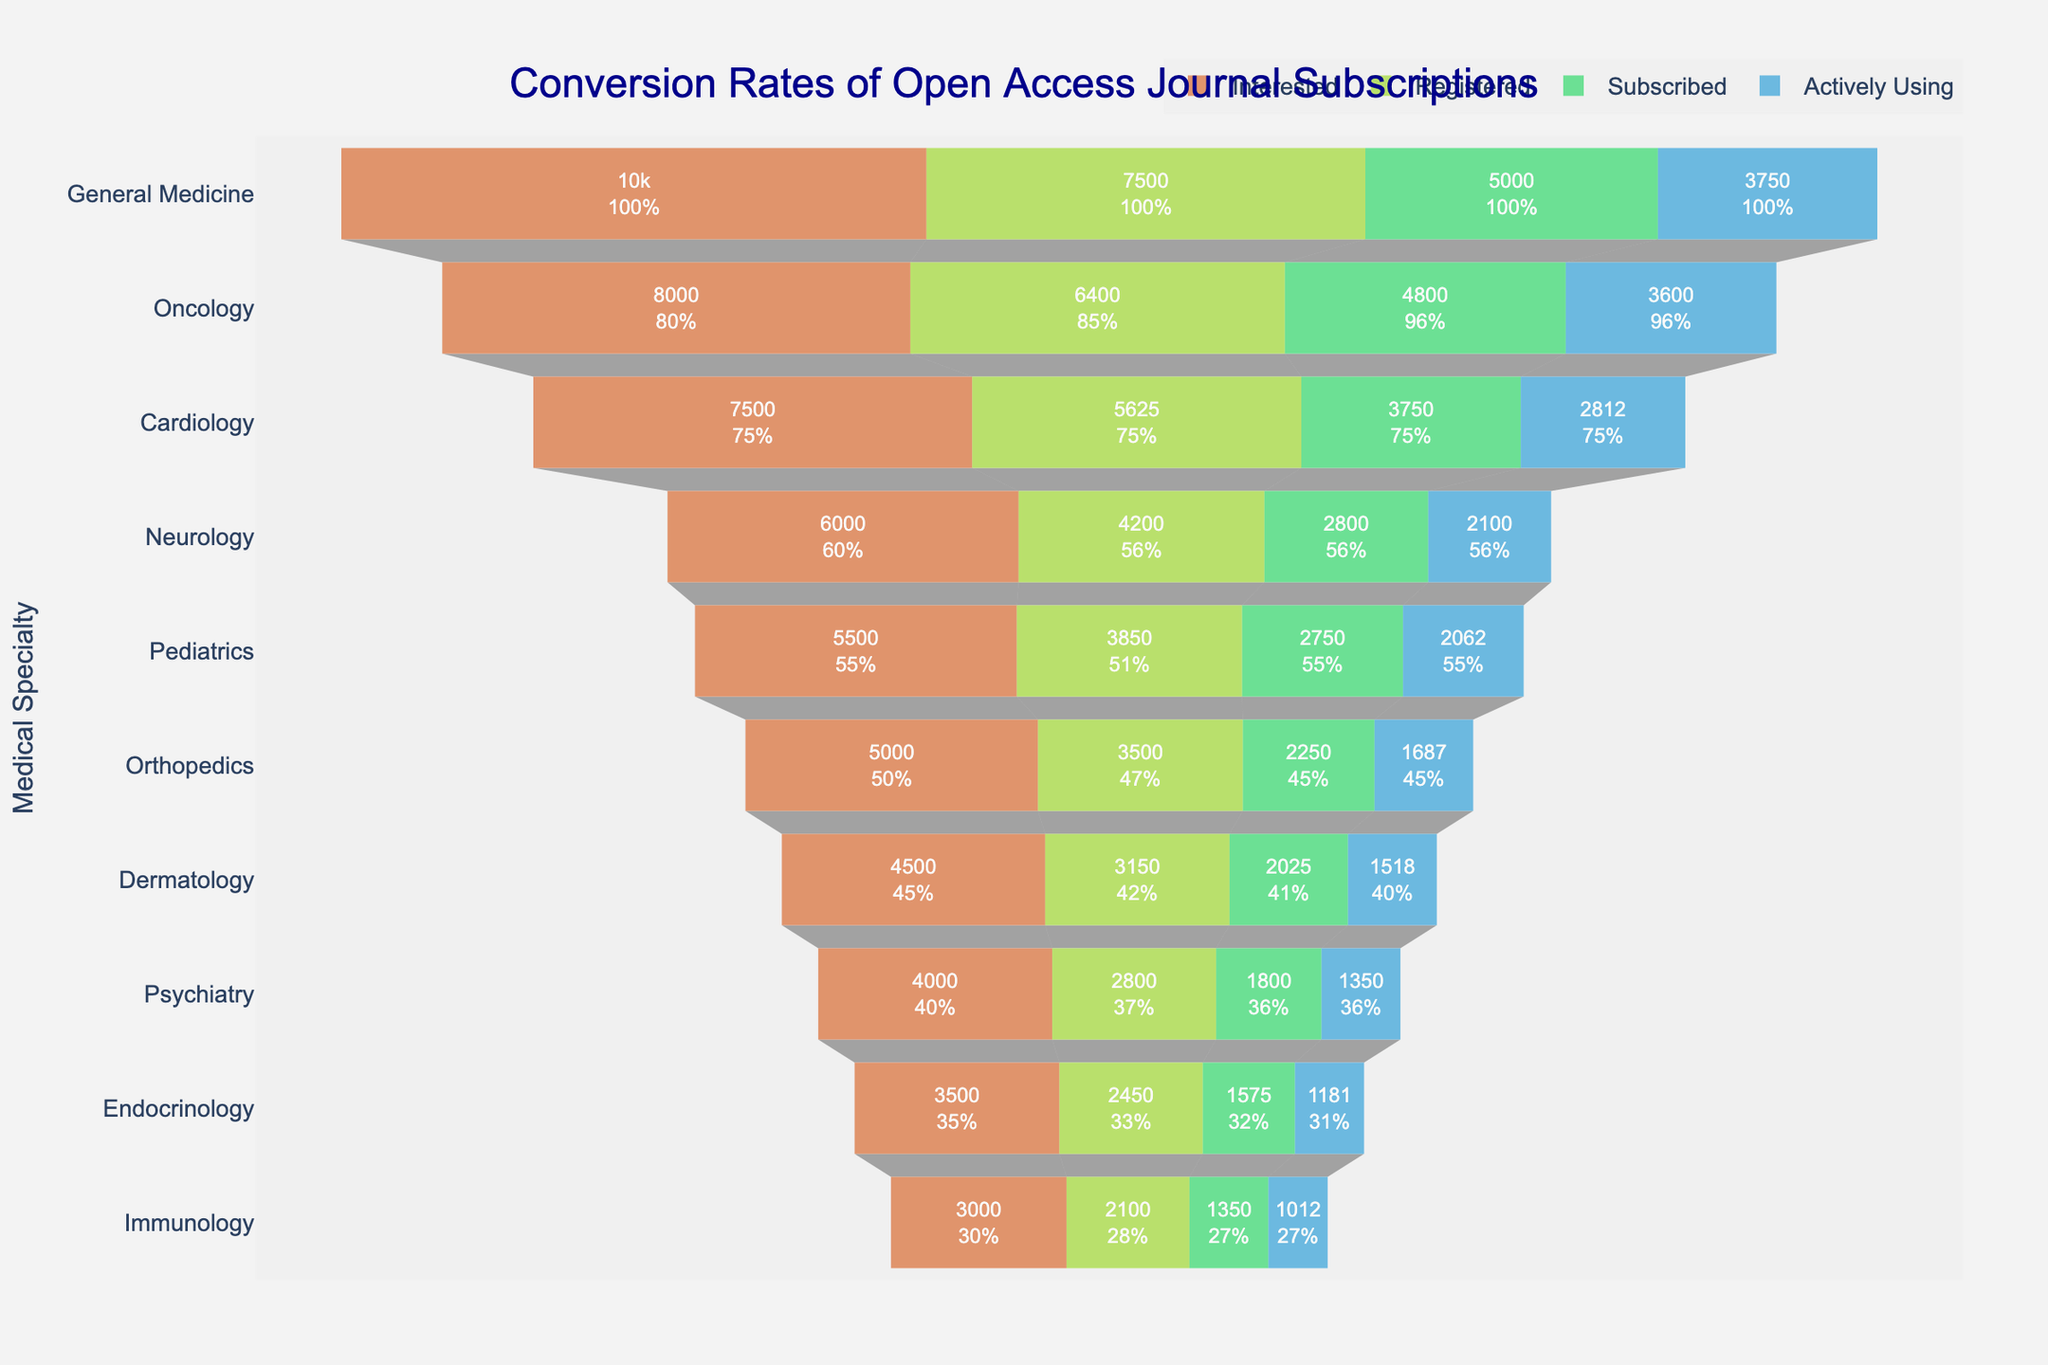What is the title of the funnel chart? The title of the funnel chart is mentioned at the top of the figure.
Answer: Conversion Rates of Open Access Journal Subscriptions How many stages are represented in the funnel chart? The stages are represented by different colored sections for each specialty.
Answer: Four Which medical specialty has the highest number of 'Interested' researchers? Look at the 'Interested' stage for each specialty and compare the values.
Answer: General Medicine What is the percentage drop from 'Registered' to 'Subscribed' in Oncology? The value for 'Registered' is 6400 and for 'Subscribed' is 4800. The percentage drop is calculated as ((6400-4800)/6400)*100.
Answer: 25% Which specialty has the smallest number of 'Actively Using' researchers? Look at the 'Actively Using' stage for each specialty and find the smallest value.
Answer: Immunology How many total researchers are 'Actively Using' the subscription across all specialties? Sum the 'Actively Using' values across all specialties: 3750 + 3600 + 2812 + 2100 + 2062 + 1687 + 1518 + 1350 + 1181 + 1012.
Answer: 21072 What is the ratio of 'Subscribed' to 'Registered' researchers in Cardiology? The 'Subscribed' value for Cardiology is 3750 and 'Registered' is 5625. The ratio is 3750/5625.
Answer: 2:3 How does the number of 'Registered' researchers in Dermatology compare to that in Psychiatry? Compare the values of 'Registered' stage for Dermatology (3150) and Psychiatry (2800). Dermatology has more than Psychiatry.
Answer: Dermatology > Psychiatry Which stage shows the greatest decline in numbers for most specialties? Compare the drop between each consecutive stages for most specialties and see which drop is typically larger.
Answer: 'Interested' to 'Registered' What is the average number of 'Subscribed' researchers across all specialties? Sum the 'Subscribed' values and divide by the number of specialties: (5000+4800+3750+2800+2750+2250+2025+1800+1575+1350)/10.
Answer: 2900 